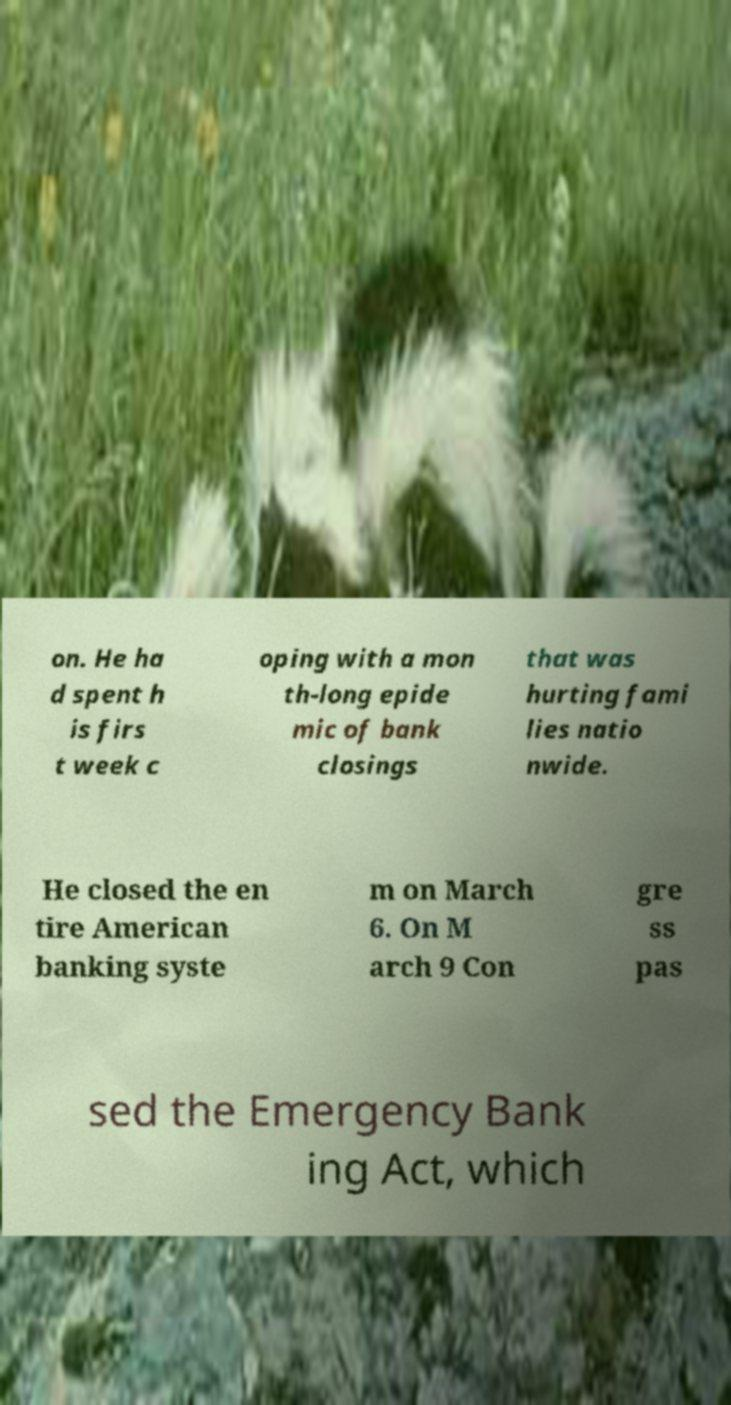I need the written content from this picture converted into text. Can you do that? on. He ha d spent h is firs t week c oping with a mon th-long epide mic of bank closings that was hurting fami lies natio nwide. He closed the en tire American banking syste m on March 6. On M arch 9 Con gre ss pas sed the Emergency Bank ing Act, which 